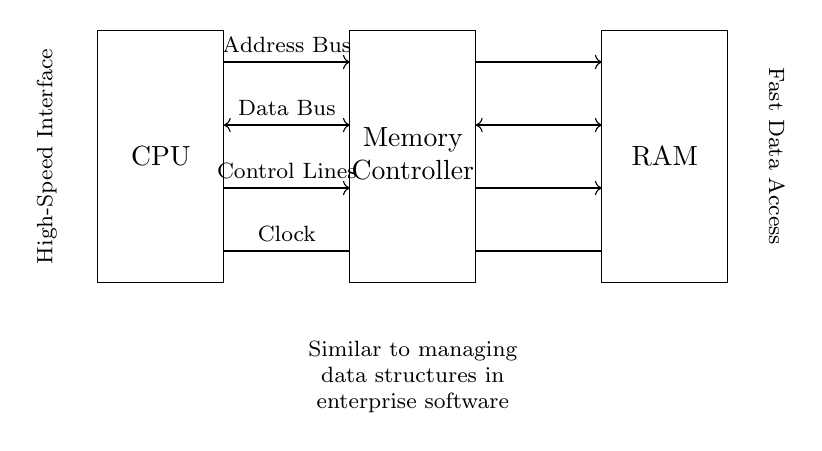What components are present in the circuit diagram? The circuit diagram includes a CPU, Memory Controller, and RAM, as indicated by the labeled boxes.
Answer: CPU, Memory Controller, RAM What are the two main buses shown in the circuit? The circuit diagram features an Address Bus and a Data Bus, which are included as arrows connecting the components.
Answer: Address Bus, Data Bus What type of signals do the control lines carry? Control lines carry signals that manage the operations of the memory system, which are depicted as arrows between the CPU and Memory Controller and between Memory Controller and RAM.
Answer: Management signals What is the purpose of the clock lines in this circuit? The clock lines provide timing signals essential for synchronizing data transfers between the CPU and memory components, marked by the horizontal line labeled "Clock."
Answer: Timing synchronization How is data communication represented in the diagram? Data communication is represented by bidirectional arrows indicating the flow of data, specifically between the CPU and Memory Controller and between the Memory Controller and RAM.
Answer: Bidirectional arrows What does the label "Fast Data Access" suggest about this memory interface? The label indicates that the memory interface is designed for high-speed data transfers, crucial for performance, which aligns with the characteristics of high-speed RAM and CPU interaction.
Answer: High-speed design Why is the phrase "Similar to managing data structures in enterprise software" included in the diagram? This phrase metaphorically compares the structured and efficient flow of data in the circuit to how data is managed in enterprise software, emphasizing the importance of organization and speed in both contexts.
Answer: Efficiency comparison 